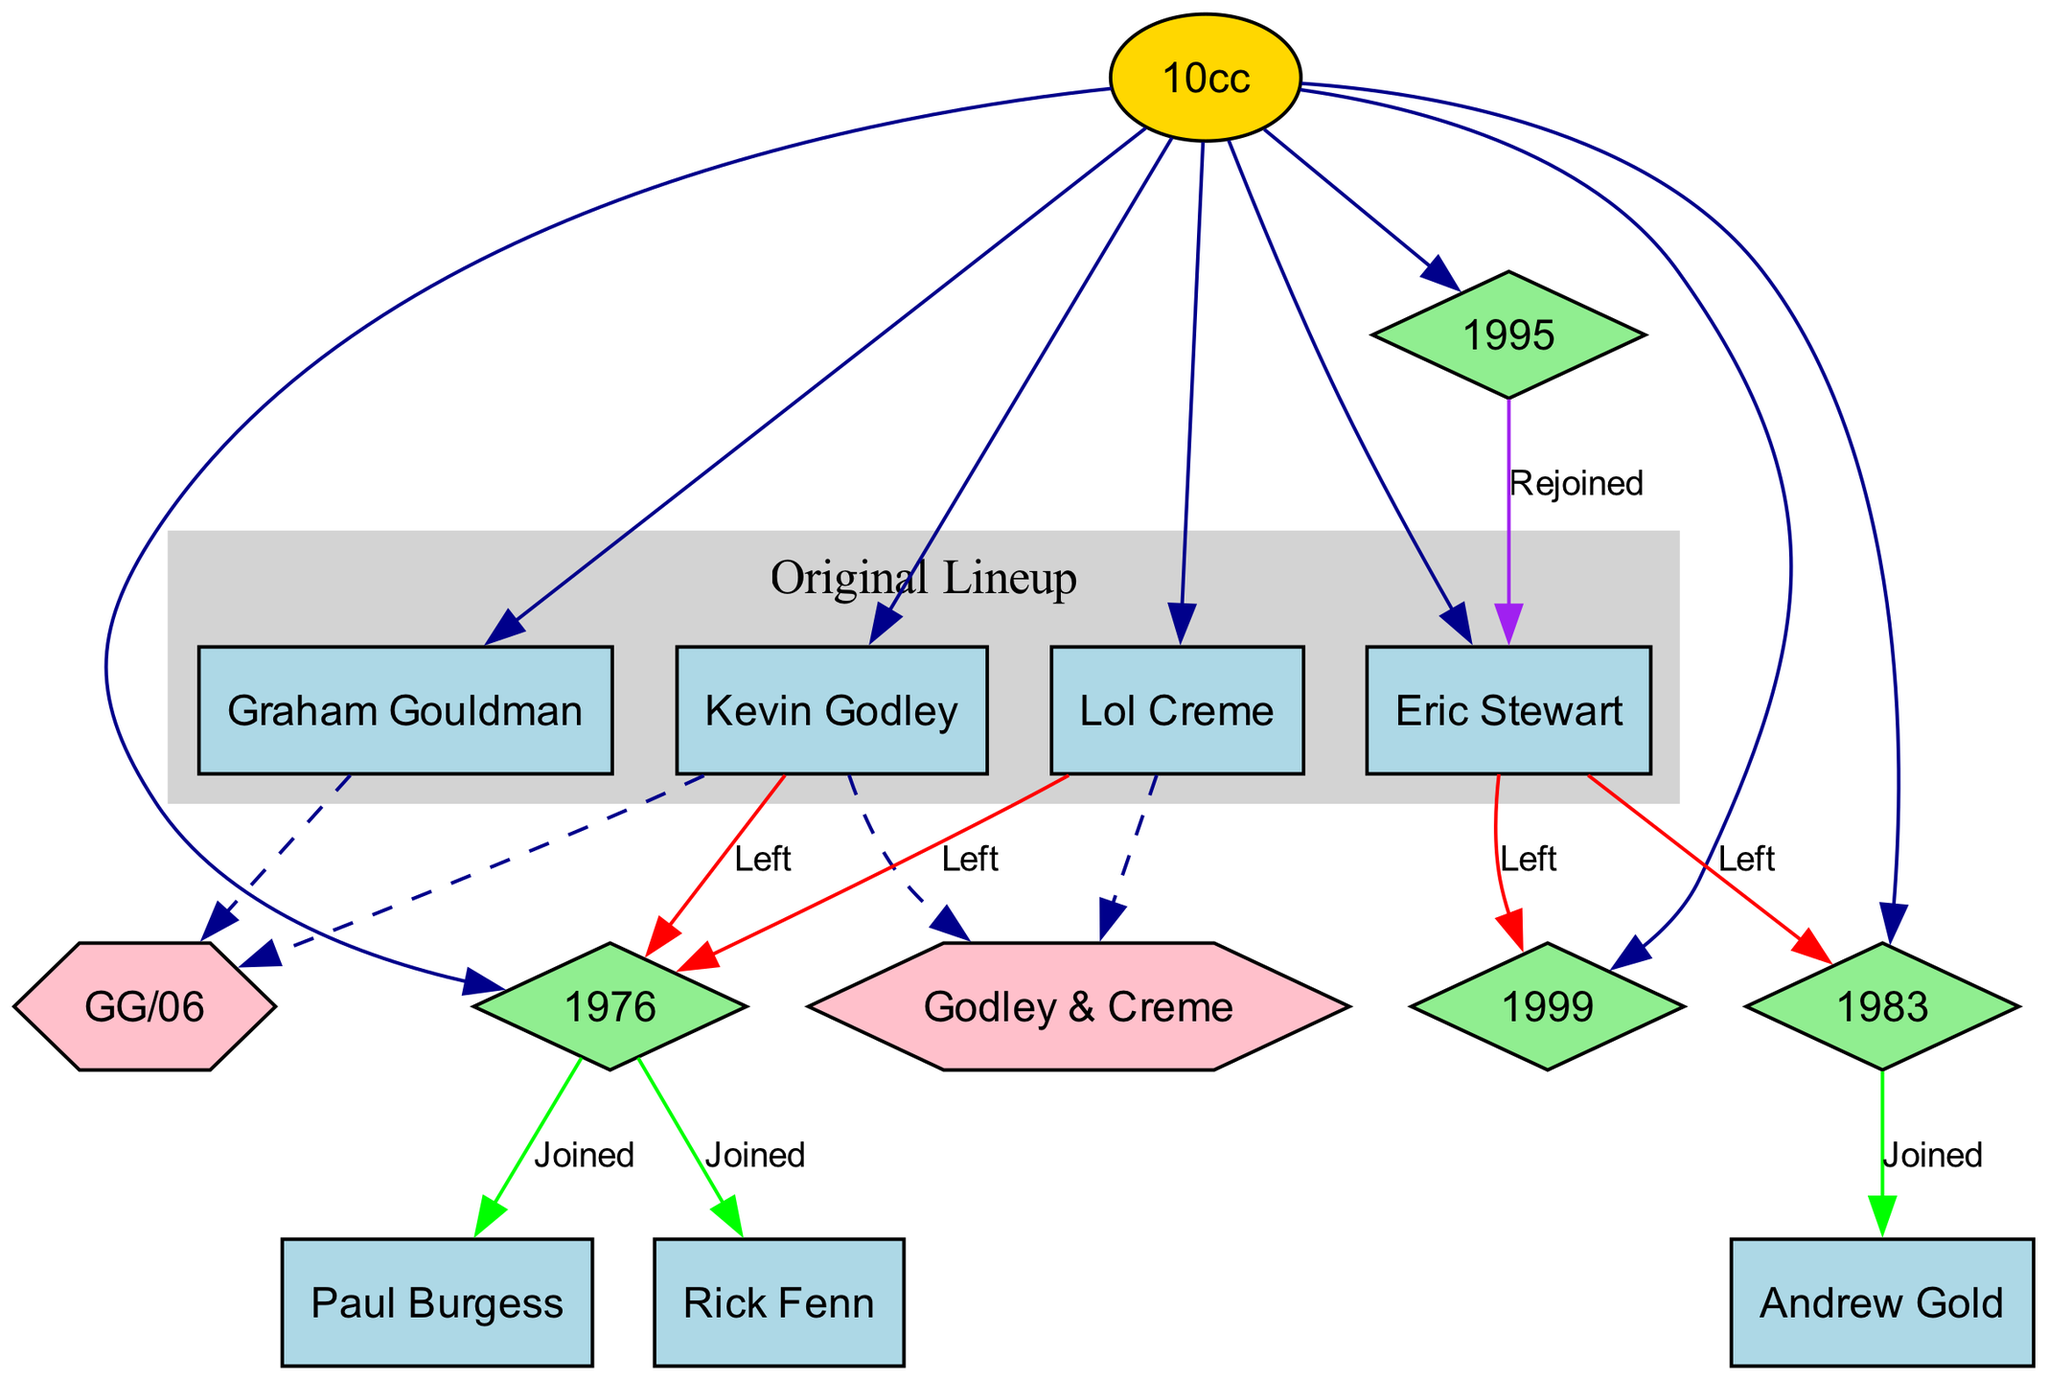What are the names of the original members of 10cc? The diagram lists the original lineup as Eric Stewart, Graham Gouldman, Kevin Godley, and Lol Creme.
Answer: Eric Stewart, Graham Gouldman, Kevin Godley, Lol Creme How many members were in the original lineup of 10cc? The original lineup includes four members: Eric Stewart, Graham Gouldman, Kevin Godley, and Lol Creme. Counting these gives us four members.
Answer: 4 In which year did Kevin Godley and Lol Creme leave the band? According to the diagram, both Kevin Godley and Lol Creme left the band in 1976, as indicated by the node for that year.
Answer: 1976 Who joined 10cc after Eric Stewart left in 1983? The diagram shows that Andrew Gold joined 10cc after Eric Stewart left in 1983. Thus, the answer focuses on the member who replaced him.
Answer: Andrew Gold What shape is used to represent member changes in the family tree? The diagram uses diamond shapes to denote significant member changes over the years. This can be visually confirmed by looking at the year nodes.
Answer: Diamond Which two members worked together in the side project "Godley & Creme"? The diagram clearly indicates that Godley & Creme consisted of Kevin Godley and Lol Creme. Both names are connected to the project node.
Answer: Kevin Godley, Lol Creme What color represents the original lineup in the diagram? The diagram uses light grey filled nodes to represent the original lineup, which you can identify from the color designation in the subgraph.
Answer: Light grey How many members left the band in 1999? The diagram shows that one member, Eric Stewart, left in 1999, which is indicated by the respective node. Therefore, the count is just one member.
Answer: 1 Which member was marked as rejoining the band in 1995? Looking at the diagram, it indicates that Eric Stewart rejoined in 1995, as represented by the label on that year's node.
Answer: Eric Stewart 